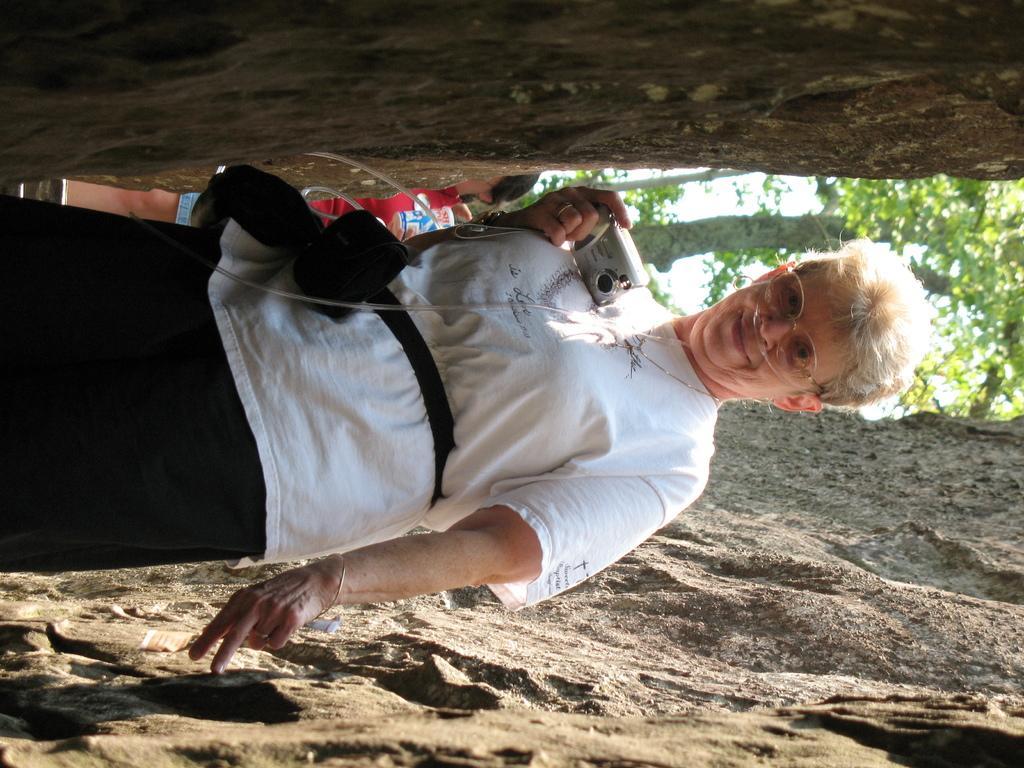In one or two sentences, can you explain what this image depicts? In this picture we can see a woman is standing and smiling, she is holding a camera, in the background we can see a tree and another person, at the top and at the bottom we can see rocks, we can also see the sky in the background. 